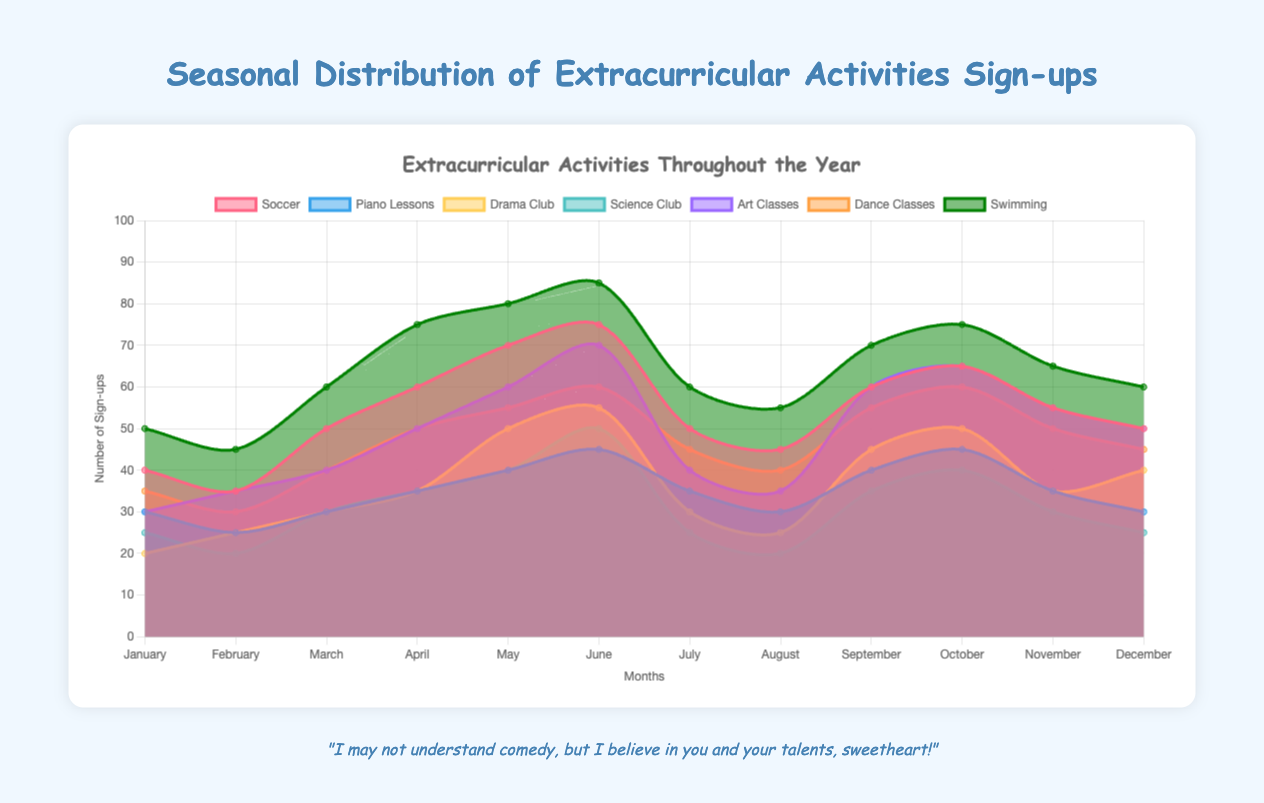What is the title of the chart? Look at the top of the chart where the title is usually placed.
Answer: Extracurricular Activities Throughout the Year What is the total number of Soccer sign-ups in January and February combined? Add the Soccer sign-ups in January (40) and February (35). 40 + 35 = 75
Answer: 75 Which activity had the highest number of sign-ups in June? Find the highest value for June across all activities. Swimming has 85 sign-ups.
Answer: Swimming How does the number of Piano Lessons sign-ups in December compare to March? Compare the values: December has 30 and March has 30. They are equal.
Answer: Equal In which month did Drama Club see its highest number of sign-ups? Look for the peak value in the Drama Club data, which is 55 in June.
Answer: June What is the average number of Art Classes sign-ups over the entire year? Add up the Art Classes sign-ups for all months and divide by 12. (30 + 35 + 40 + 50 + 60 + 70 + 40 + 35 + 60 + 65 + 55 + 50) / 12 = 48.33
Answer: 48.33 Which activity consistently has a higher number of sign-ups: Science Club or Piano Lessons? Compare monthly sign-ups for both activities and determine the consistent trends. For most months, Science Club sign-ups are equal to or less than Piano Lessons.
Answer: Piano Lessons What patterns can you identify in Swimming sign-ups throughout the year? Observe trends in Swimming sign-ups: they increase from January to June (50 to 85), slightly decrease in July (60) and August (55), then rise again in September and October before decreasing toward the end of the year.
Answer: Increase, peak in June, slight drop in summer, another rise in fall, and decrease at year-end 